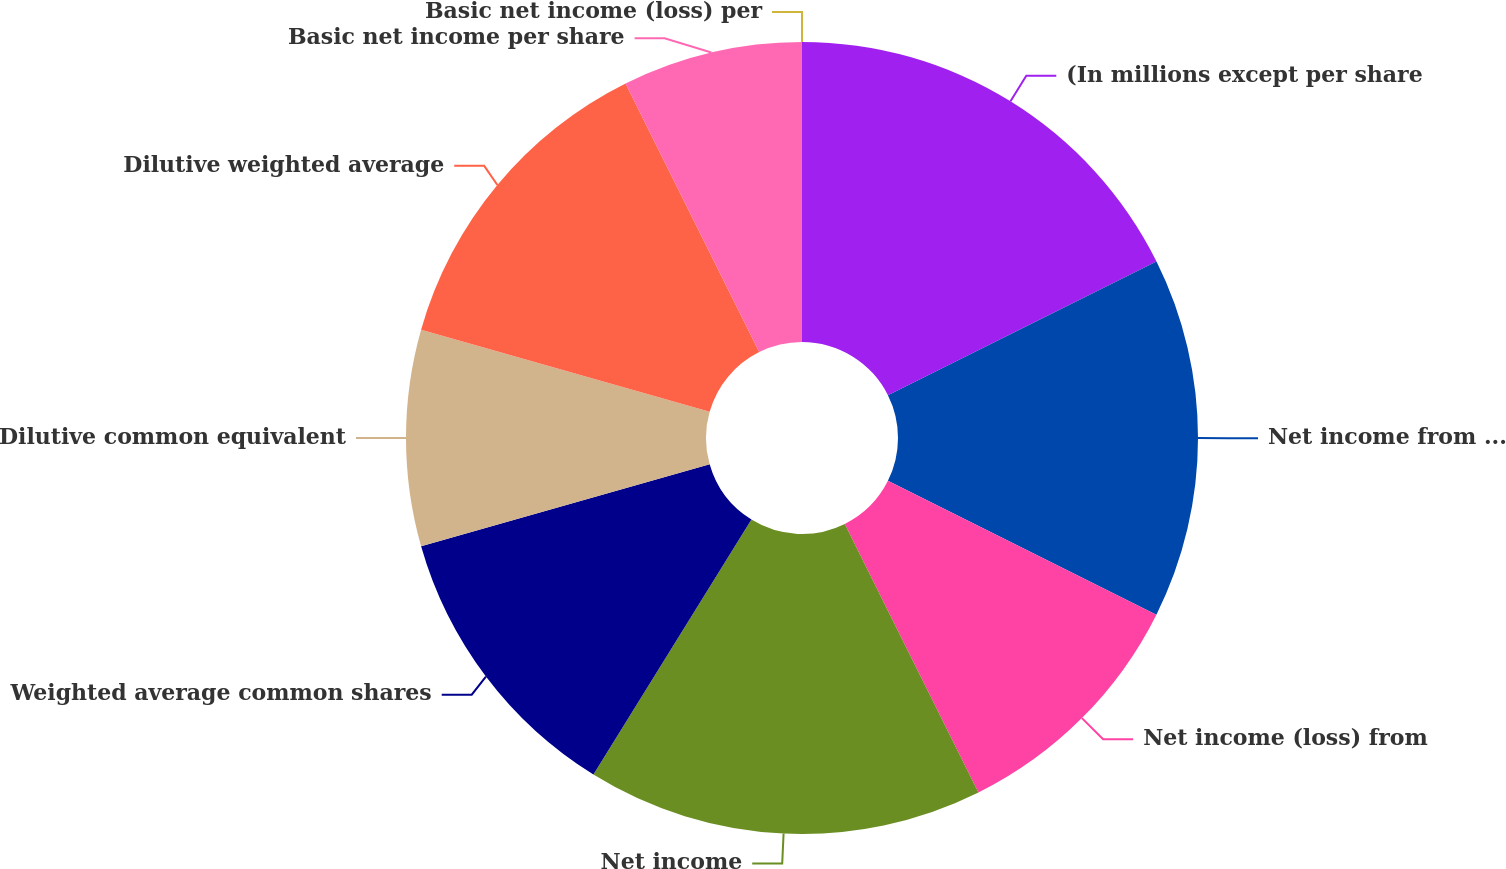Convert chart to OTSL. <chart><loc_0><loc_0><loc_500><loc_500><pie_chart><fcel>(In millions except per share<fcel>Net income from continuing<fcel>Net income (loss) from<fcel>Net income<fcel>Weighted average common shares<fcel>Dilutive common equivalent<fcel>Dilutive weighted average<fcel>Basic net income per share<fcel>Basic net income (loss) per<nl><fcel>17.65%<fcel>14.71%<fcel>10.29%<fcel>16.18%<fcel>11.76%<fcel>8.82%<fcel>13.24%<fcel>7.35%<fcel>0.0%<nl></chart> 